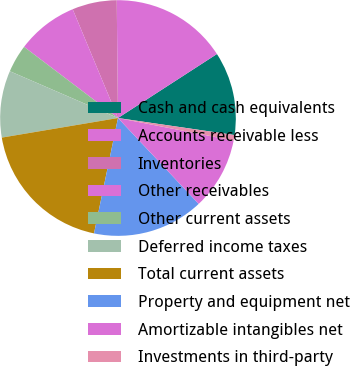<chart> <loc_0><loc_0><loc_500><loc_500><pie_chart><fcel>Cash and cash equivalents<fcel>Accounts receivable less<fcel>Inventories<fcel>Other receivables<fcel>Other current assets<fcel>Deferred income taxes<fcel>Total current assets<fcel>Property and equipment net<fcel>Amortizable intangibles net<fcel>Investments in third-party<nl><fcel>11.45%<fcel>16.03%<fcel>6.11%<fcel>8.4%<fcel>3.82%<fcel>9.16%<fcel>19.08%<fcel>15.27%<fcel>9.92%<fcel>0.76%<nl></chart> 